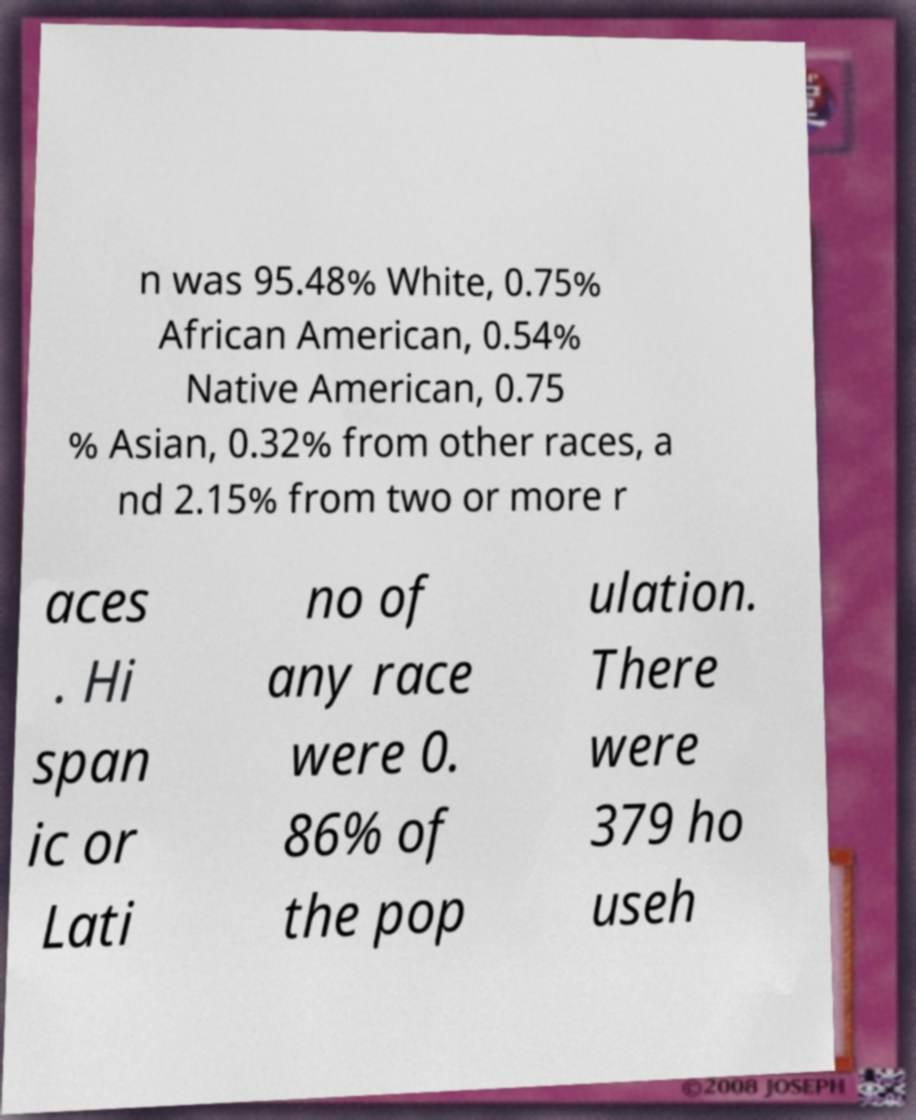There's text embedded in this image that I need extracted. Can you transcribe it verbatim? n was 95.48% White, 0.75% African American, 0.54% Native American, 0.75 % Asian, 0.32% from other races, a nd 2.15% from two or more r aces . Hi span ic or Lati no of any race were 0. 86% of the pop ulation. There were 379 ho useh 